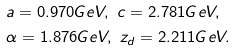<formula> <loc_0><loc_0><loc_500><loc_500>& a = 0 . 9 7 0 G e V , \ c = 2 . 7 8 1 G e V , \\ & \alpha = 1 . 8 7 6 G e V , \ z _ { d } = 2 . 2 1 1 G e V .</formula> 